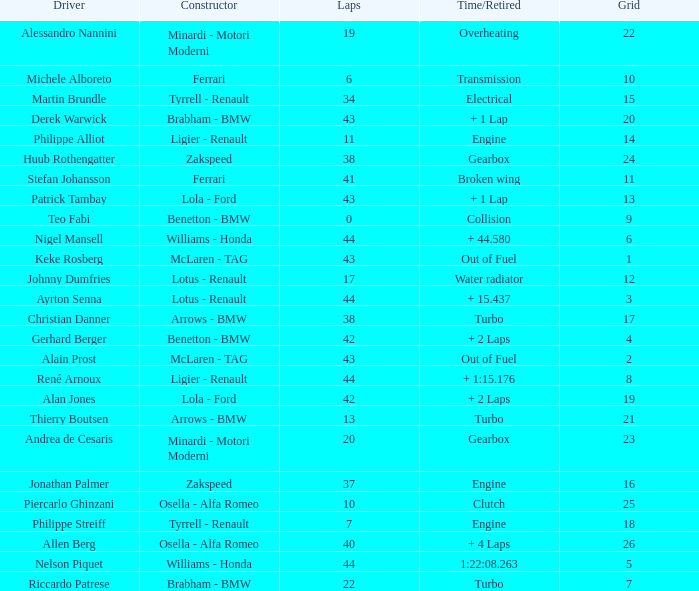I want the driver that has Laps of 10 Piercarlo Ghinzani. 